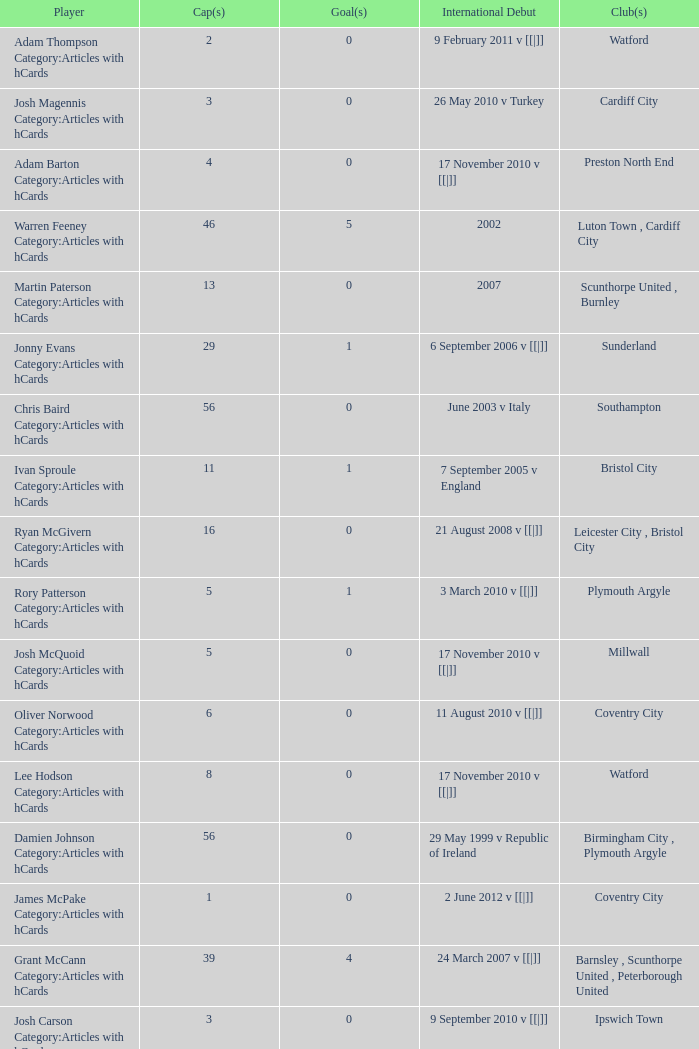How many caps figures for the Doncaster Rovers? 1.0. 